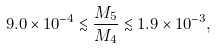Convert formula to latex. <formula><loc_0><loc_0><loc_500><loc_500>9 . 0 \times 1 0 ^ { - 4 } \lesssim \frac { M _ { 5 } } { M _ { 4 } } \lesssim 1 . 9 \times 1 0 ^ { - 3 } ,</formula> 